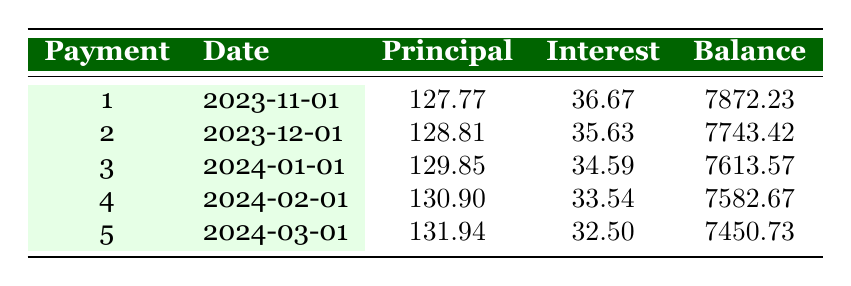What is the total payment amount for the loan? The monthly payment for the loan is 152.77. The loan term is 5 years, which means there are 60 payments (12 payments per year × 5 years). The total payment amount is 152.77 × 60 = 9166.20.
Answer: 9166.20 What is the principal payment for the first month? The table shows that the principal payment for the first month is 127.77.
Answer: 127.77 How much interest is paid in the second month? According to the table, the interest payment for the second month is 35.63.
Answer: 35.63 What is the remaining balance after the third payment? The remaining balance after the third payment is listed in the table as 7613.57.
Answer: 7613.57 Is the principal payment increasing with each successive payment? Yes, the principal payments are increasing month by month: 127.77, 128.81, 129.85, etc. This indicates that more of the monthly payment goes toward the principal as time goes on.
Answer: Yes How much total interest will be paid by the end of the five years? To find the total interest paid, we can sum the interest payments for the first five payments: 36.67 + 35.63 + 34.59 + 33.54 + 32.50 = 172.93. However, we will need to continue this calculation for all 60 payments to get the complete total. Thus, using the monthly interest rate from the loan details, we calculate the total interest paid over the life of the loan. The detailed calculation requires summing all interest payments or determining based on the known total payments versus the loan amount.
Answer: Total interest will be higher than 172.93 What is the average principal payment over the first five months? To find the average principal payment over the first five months, we sum the principal payments: 127.77 + 128.81 + 129.85 + 130.90 + 131.94 = 649.27. Then divide by 5 for the average: 649.27 / 5 = 129.85.
Answer: 129.85 How does the interest payment for the fourth month compare to that for the first month? The interest payment for the first month is 36.67, while that for the fourth month is 33.54. By comparing both, we find that the interest payment decreased as the loan balance was reduced through payments.
Answer: It decreased 